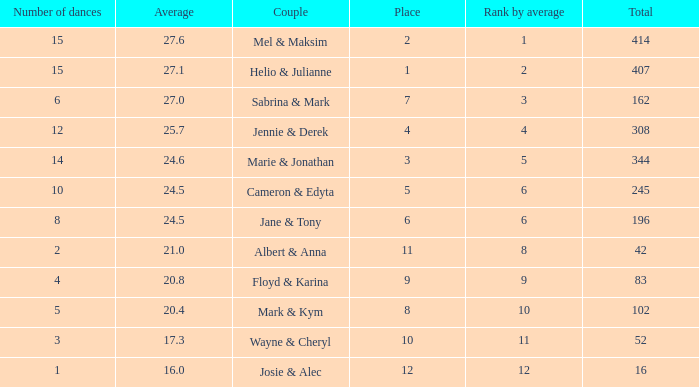What is the rank by average where the total was larger than 245 and the average was 27.1 with fewer than 15 dances? None. 